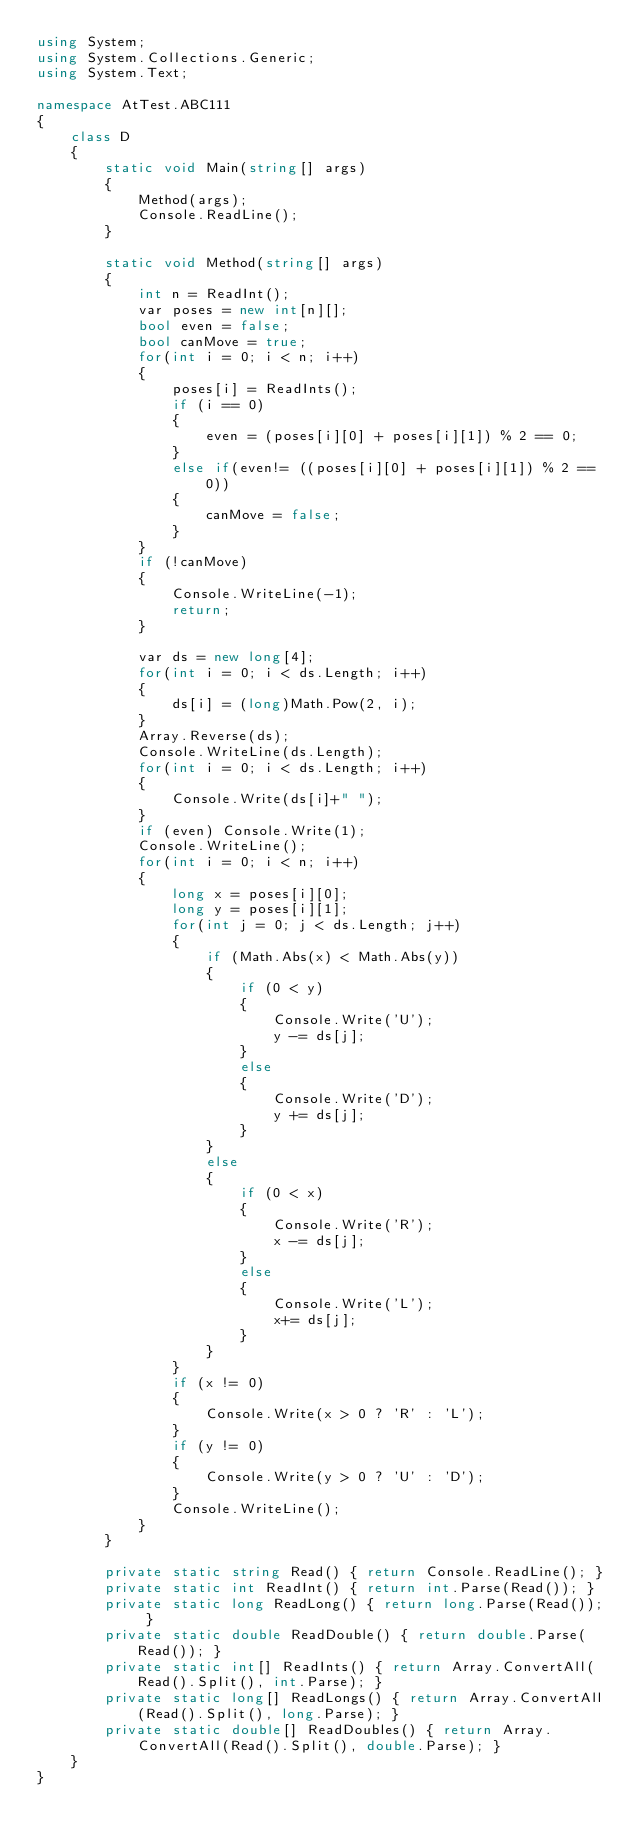Convert code to text. <code><loc_0><loc_0><loc_500><loc_500><_C#_>using System;
using System.Collections.Generic;
using System.Text;

namespace AtTest.ABC111
{
    class D
    {
        static void Main(string[] args)
        {
            Method(args);
            Console.ReadLine();
        }

        static void Method(string[] args)
        {
            int n = ReadInt();
            var poses = new int[n][];
            bool even = false;
            bool canMove = true;
            for(int i = 0; i < n; i++)
            {
                poses[i] = ReadInts();
                if (i == 0)
                {
                    even = (poses[i][0] + poses[i][1]) % 2 == 0;
                }
                else if(even!= ((poses[i][0] + poses[i][1]) % 2 == 0))
                {
                    canMove = false;
                }
            }
            if (!canMove)
            {
                Console.WriteLine(-1);
                return;
            }

            var ds = new long[4];
            for(int i = 0; i < ds.Length; i++)
            {
                ds[i] = (long)Math.Pow(2, i);
            }
            Array.Reverse(ds);
            Console.WriteLine(ds.Length);
            for(int i = 0; i < ds.Length; i++)
            {
                Console.Write(ds[i]+" ");
            }
            if (even) Console.Write(1);
            Console.WriteLine();
            for(int i = 0; i < n; i++)
            {
                long x = poses[i][0];
                long y = poses[i][1];
                for(int j = 0; j < ds.Length; j++)
                {
                    if (Math.Abs(x) < Math.Abs(y))
                    {
                        if (0 < y)
                        {
                            Console.Write('U');
                            y -= ds[j];
                        }
                        else
                        {
                            Console.Write('D');
                            y += ds[j];
                        }
                    }
                    else
                    {
                        if (0 < x)
                        {
                            Console.Write('R');
                            x -= ds[j];
                        }
                        else
                        {
                            Console.Write('L');
                            x+= ds[j];
                        }
                    }
                }
                if (x != 0)
                {
                    Console.Write(x > 0 ? 'R' : 'L');
                }
                if (y != 0)
                {
                    Console.Write(y > 0 ? 'U' : 'D');
                }
                Console.WriteLine();
            }
        }

        private static string Read() { return Console.ReadLine(); }
        private static int ReadInt() { return int.Parse(Read()); }
        private static long ReadLong() { return long.Parse(Read()); }
        private static double ReadDouble() { return double.Parse(Read()); }
        private static int[] ReadInts() { return Array.ConvertAll(Read().Split(), int.Parse); }
        private static long[] ReadLongs() { return Array.ConvertAll(Read().Split(), long.Parse); }
        private static double[] ReadDoubles() { return Array.ConvertAll(Read().Split(), double.Parse); }
    }
}
</code> 